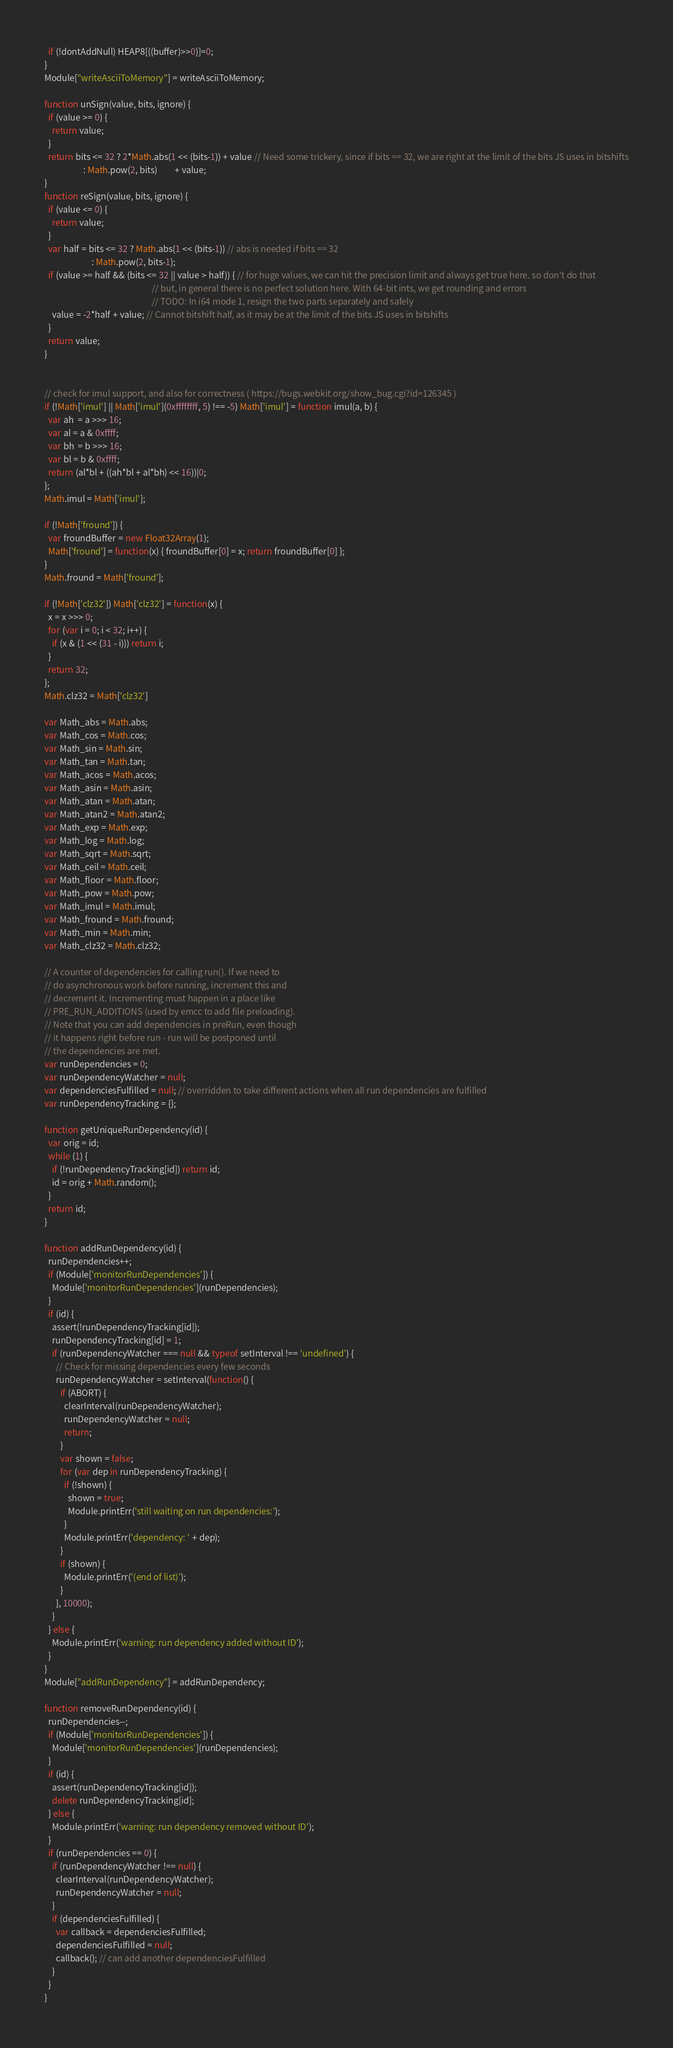<code> <loc_0><loc_0><loc_500><loc_500><_JavaScript_>  if (!dontAddNull) HEAP8[((buffer)>>0)]=0;
}
Module["writeAsciiToMemory"] = writeAsciiToMemory;

function unSign(value, bits, ignore) {
  if (value >= 0) {
    return value;
  }
  return bits <= 32 ? 2*Math.abs(1 << (bits-1)) + value // Need some trickery, since if bits == 32, we are right at the limit of the bits JS uses in bitshifts
                    : Math.pow(2, bits)         + value;
}
function reSign(value, bits, ignore) {
  if (value <= 0) {
    return value;
  }
  var half = bits <= 32 ? Math.abs(1 << (bits-1)) // abs is needed if bits == 32
                        : Math.pow(2, bits-1);
  if (value >= half && (bits <= 32 || value > half)) { // for huge values, we can hit the precision limit and always get true here. so don't do that
                                                       // but, in general there is no perfect solution here. With 64-bit ints, we get rounding and errors
                                                       // TODO: In i64 mode 1, resign the two parts separately and safely
    value = -2*half + value; // Cannot bitshift half, as it may be at the limit of the bits JS uses in bitshifts
  }
  return value;
}


// check for imul support, and also for correctness ( https://bugs.webkit.org/show_bug.cgi?id=126345 )
if (!Math['imul'] || Math['imul'](0xffffffff, 5) !== -5) Math['imul'] = function imul(a, b) {
  var ah  = a >>> 16;
  var al = a & 0xffff;
  var bh  = b >>> 16;
  var bl = b & 0xffff;
  return (al*bl + ((ah*bl + al*bh) << 16))|0;
};
Math.imul = Math['imul'];

if (!Math['fround']) {
  var froundBuffer = new Float32Array(1);
  Math['fround'] = function(x) { froundBuffer[0] = x; return froundBuffer[0] };
}
Math.fround = Math['fround'];

if (!Math['clz32']) Math['clz32'] = function(x) {
  x = x >>> 0;
  for (var i = 0; i < 32; i++) {
    if (x & (1 << (31 - i))) return i;
  }
  return 32;
};
Math.clz32 = Math['clz32']

var Math_abs = Math.abs;
var Math_cos = Math.cos;
var Math_sin = Math.sin;
var Math_tan = Math.tan;
var Math_acos = Math.acos;
var Math_asin = Math.asin;
var Math_atan = Math.atan;
var Math_atan2 = Math.atan2;
var Math_exp = Math.exp;
var Math_log = Math.log;
var Math_sqrt = Math.sqrt;
var Math_ceil = Math.ceil;
var Math_floor = Math.floor;
var Math_pow = Math.pow;
var Math_imul = Math.imul;
var Math_fround = Math.fround;
var Math_min = Math.min;
var Math_clz32 = Math.clz32;

// A counter of dependencies for calling run(). If we need to
// do asynchronous work before running, increment this and
// decrement it. Incrementing must happen in a place like
// PRE_RUN_ADDITIONS (used by emcc to add file preloading).
// Note that you can add dependencies in preRun, even though
// it happens right before run - run will be postponed until
// the dependencies are met.
var runDependencies = 0;
var runDependencyWatcher = null;
var dependenciesFulfilled = null; // overridden to take different actions when all run dependencies are fulfilled
var runDependencyTracking = {};

function getUniqueRunDependency(id) {
  var orig = id;
  while (1) {
    if (!runDependencyTracking[id]) return id;
    id = orig + Math.random();
  }
  return id;
}

function addRunDependency(id) {
  runDependencies++;
  if (Module['monitorRunDependencies']) {
    Module['monitorRunDependencies'](runDependencies);
  }
  if (id) {
    assert(!runDependencyTracking[id]);
    runDependencyTracking[id] = 1;
    if (runDependencyWatcher === null && typeof setInterval !== 'undefined') {
      // Check for missing dependencies every few seconds
      runDependencyWatcher = setInterval(function() {
        if (ABORT) {
          clearInterval(runDependencyWatcher);
          runDependencyWatcher = null;
          return;
        }
        var shown = false;
        for (var dep in runDependencyTracking) {
          if (!shown) {
            shown = true;
            Module.printErr('still waiting on run dependencies:');
          }
          Module.printErr('dependency: ' + dep);
        }
        if (shown) {
          Module.printErr('(end of list)');
        }
      }, 10000);
    }
  } else {
    Module.printErr('warning: run dependency added without ID');
  }
}
Module["addRunDependency"] = addRunDependency;

function removeRunDependency(id) {
  runDependencies--;
  if (Module['monitorRunDependencies']) {
    Module['monitorRunDependencies'](runDependencies);
  }
  if (id) {
    assert(runDependencyTracking[id]);
    delete runDependencyTracking[id];
  } else {
    Module.printErr('warning: run dependency removed without ID');
  }
  if (runDependencies == 0) {
    if (runDependencyWatcher !== null) {
      clearInterval(runDependencyWatcher);
      runDependencyWatcher = null;
    }
    if (dependenciesFulfilled) {
      var callback = dependenciesFulfilled;
      dependenciesFulfilled = null;
      callback(); // can add another dependenciesFulfilled
    }
  }
}</code> 